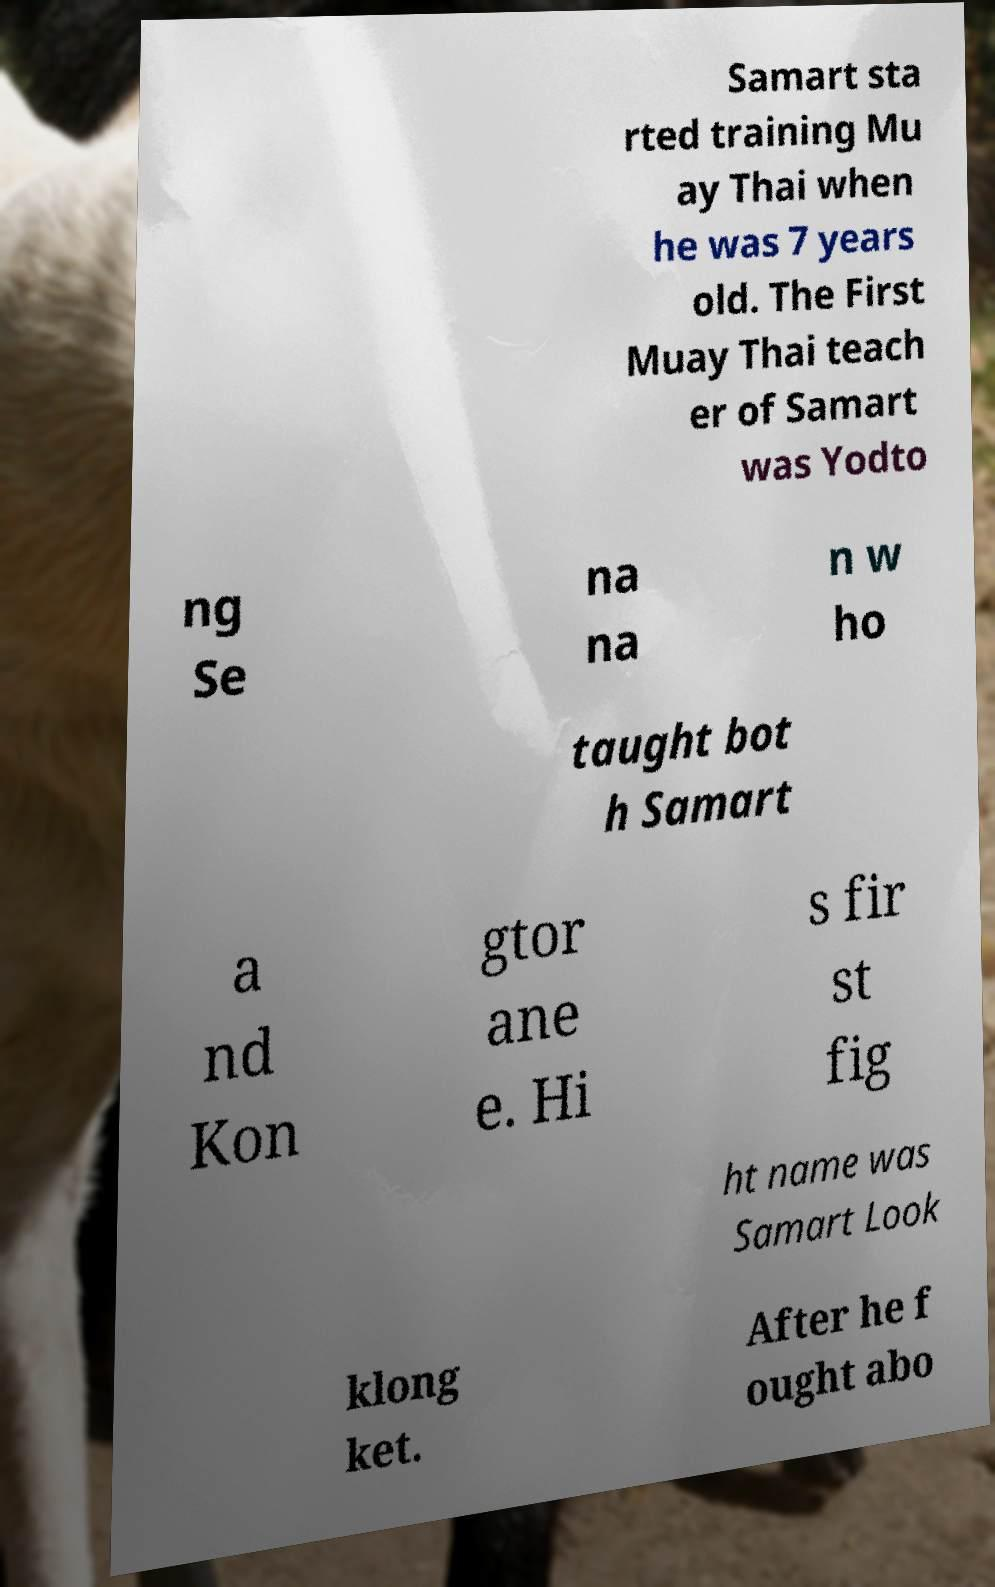There's text embedded in this image that I need extracted. Can you transcribe it verbatim? Samart sta rted training Mu ay Thai when he was 7 years old. The First Muay Thai teach er of Samart was Yodto ng Se na na n w ho taught bot h Samart a nd Kon gtor ane e. Hi s fir st fig ht name was Samart Look klong ket. After he f ought abo 